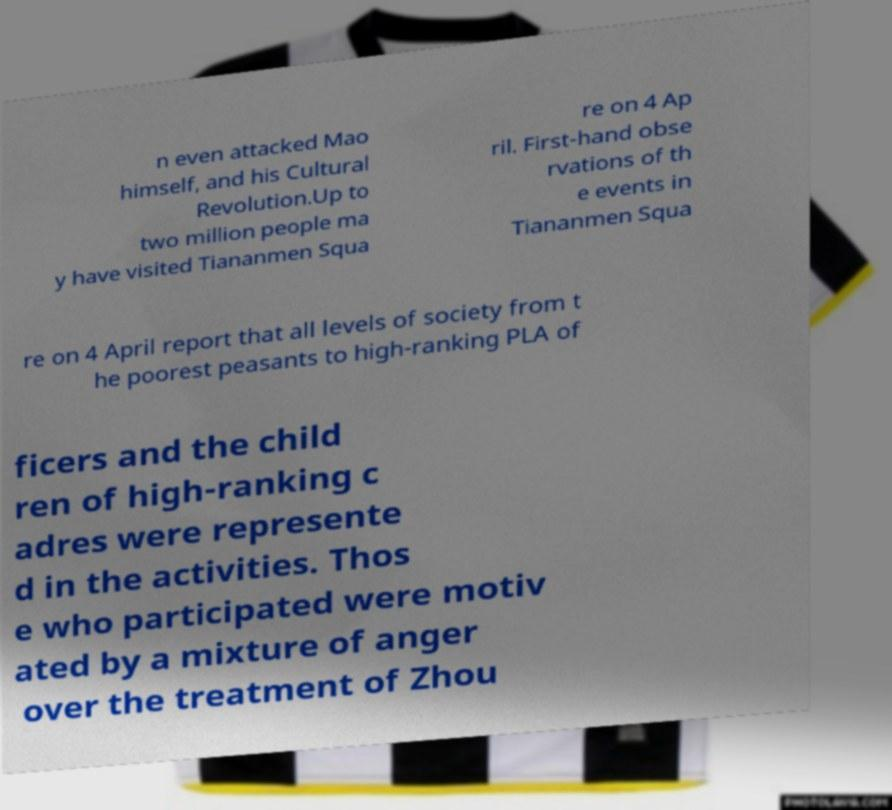What messages or text are displayed in this image? I need them in a readable, typed format. n even attacked Mao himself, and his Cultural Revolution.Up to two million people ma y have visited Tiananmen Squa re on 4 Ap ril. First-hand obse rvations of th e events in Tiananmen Squa re on 4 April report that all levels of society from t he poorest peasants to high-ranking PLA of ficers and the child ren of high-ranking c adres were represente d in the activities. Thos e who participated were motiv ated by a mixture of anger over the treatment of Zhou 